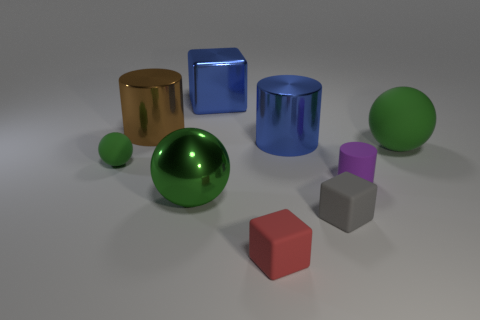Subtract all yellow cylinders. Subtract all cyan cubes. How many cylinders are left? 3 Subtract all cylinders. How many objects are left? 6 Subtract all small yellow matte cylinders. Subtract all tiny red rubber objects. How many objects are left? 8 Add 6 tiny red rubber objects. How many tiny red rubber objects are left? 7 Add 9 gray cubes. How many gray cubes exist? 10 Subtract 1 blue cubes. How many objects are left? 8 